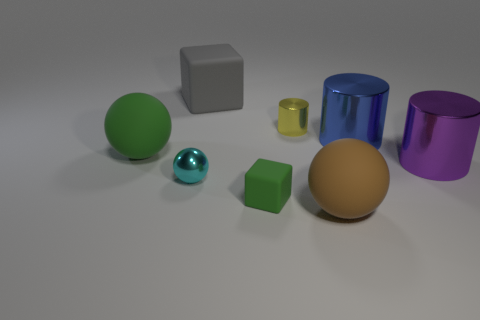Add 2 blue things. How many objects exist? 10 Subtract all blocks. How many objects are left? 6 Add 2 blue metal cylinders. How many blue metal cylinders are left? 3 Add 6 green blocks. How many green blocks exist? 7 Subtract 1 brown balls. How many objects are left? 7 Subtract all large gray blocks. Subtract all small yellow things. How many objects are left? 6 